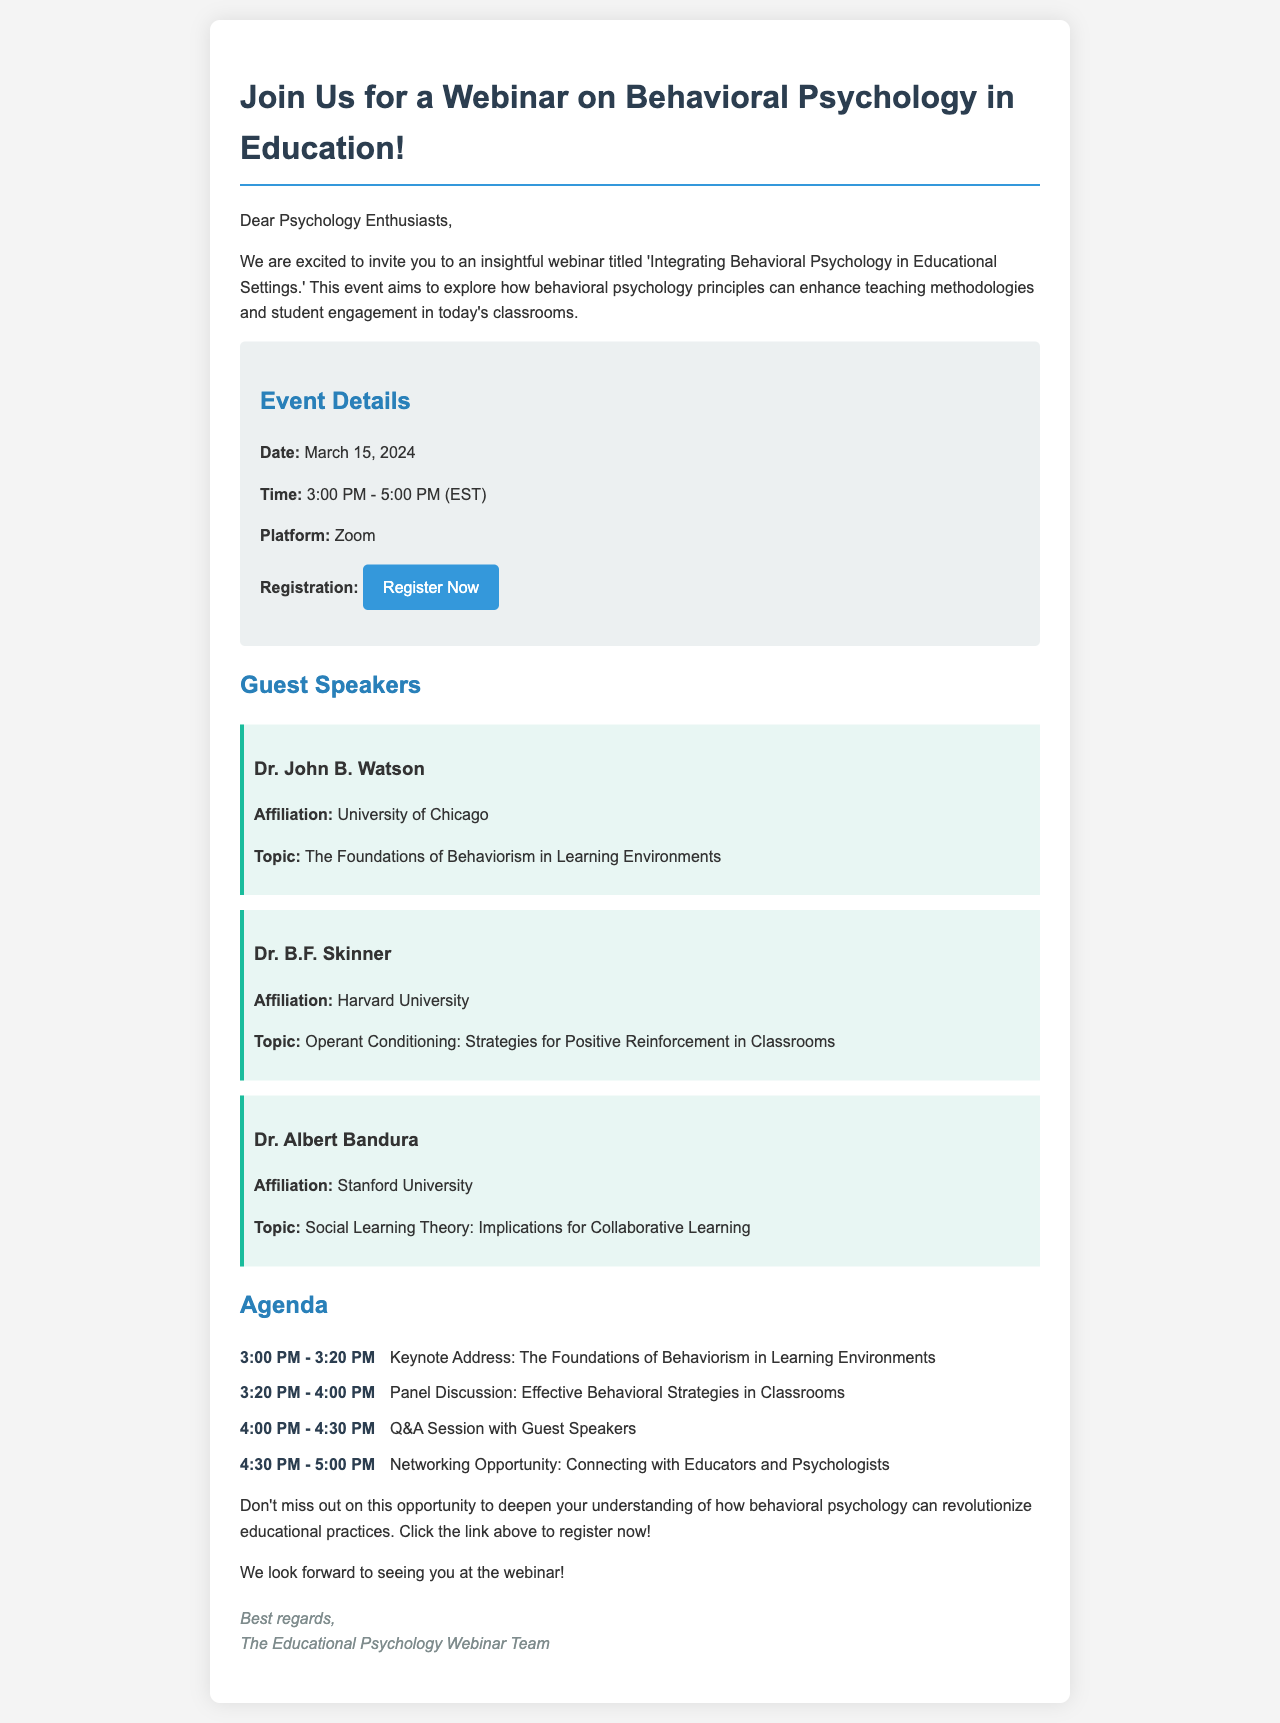What is the title of the webinar? The title of the webinar is found in the heading of the document, which is 'Integrating Behavioral Psychology in Educational Settings.'
Answer: Integrating Behavioral Psychology in Educational Settings When is the webinar scheduled? The scheduling information is provided in the event details section, specifying the date for the webinar.
Answer: March 15, 2024 What platform will be used for the webinar? The platform information is mentioned under the event details section, indicating where the virtual meeting will take place.
Answer: Zoom Who is one of the guest speakers? The guest speakers' names are listed, and one of them can be found in the section dedicated to speakers.
Answer: Dr. John B. Watson What topic will Dr. B.F. Skinner discuss? The topic of each guest speaker is given and can be found in the respective speaker section.
Answer: Operant Conditioning: Strategies for Positive Reinforcement in Classrooms What is the time for the Q&A session? The agenda outlines the specific times for each event, including the Q&A session's timing.
Answer: 4:00 PM - 4:30 PM How long will the keynote address last? The duration of the keynote address is given in the agenda, detailing how long this segment will be.
Answer: 20 minutes What opportunity will follow the Q&A session? The agenda indicates the activities planned after the Q&A session, specifying the time allotted for this segment.
Answer: Networking Opportunity: Connecting with Educators and Psychologists What can participants do through the registration link? The registration link informally allows participants to secure their spot for the event, per the document.
Answer: Register Now 